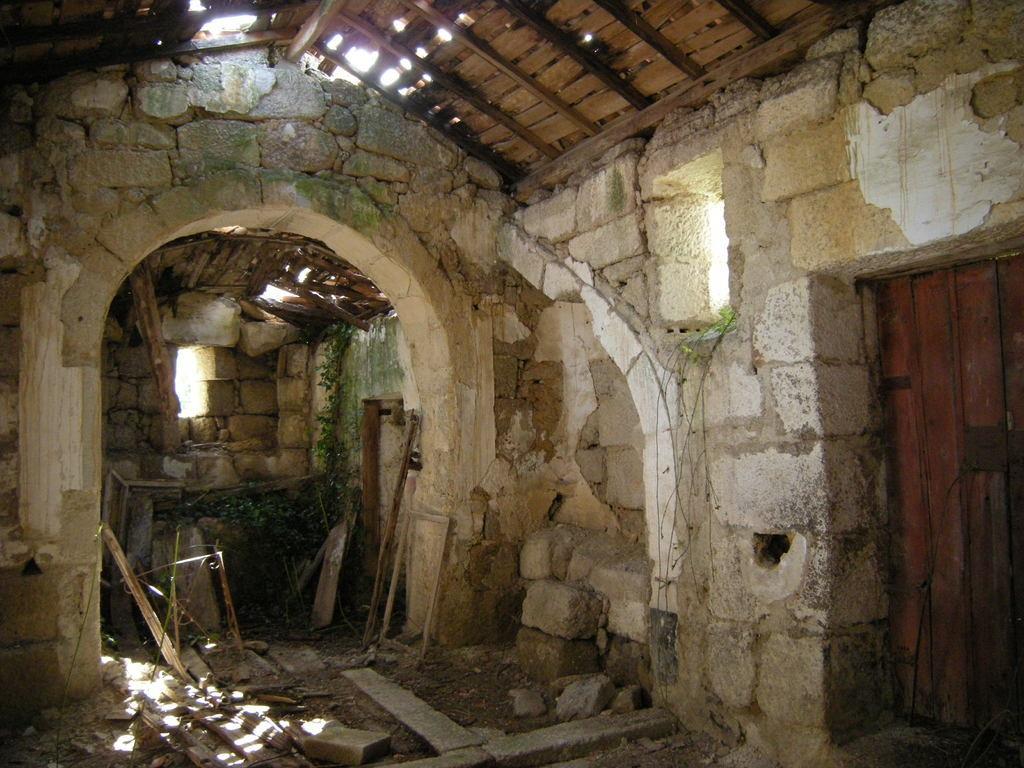In one or two sentences, can you explain what this image depicts? In this picture there is a brick wall and there is a wooden roof above it. 